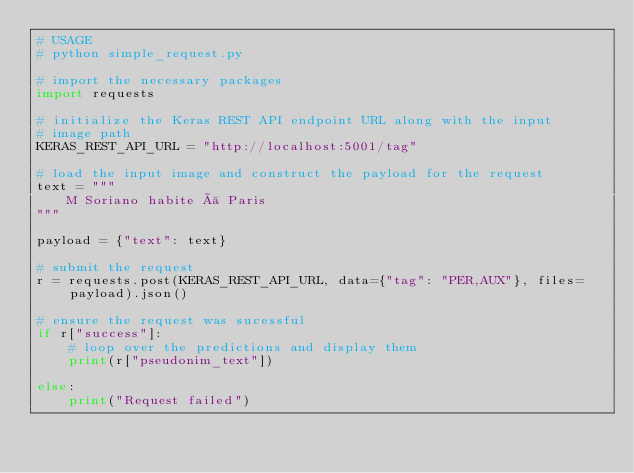Convert code to text. <code><loc_0><loc_0><loc_500><loc_500><_Python_># USAGE
# python simple_request.py

# import the necessary packages
import requests

# initialize the Keras REST API endpoint URL along with the input
# image path
KERAS_REST_API_URL = "http://localhost:5001/tag"

# load the input image and construct the payload for the request
text = """
    M Soriano habite à Paris
"""

payload = {"text": text}

# submit the request
r = requests.post(KERAS_REST_API_URL, data={"tag": "PER,AUX"}, files=payload).json()

# ensure the request was sucessful
if r["success"]:
    # loop over the predictions and display them
    print(r["pseudonim_text"])

else:
    print("Request failed")
</code> 